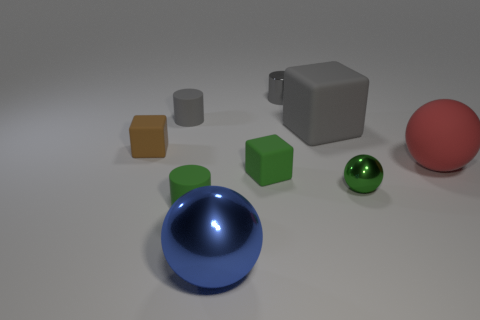Add 1 metal blocks. How many objects exist? 10 Subtract all cylinders. How many objects are left? 6 Add 2 gray cylinders. How many gray cylinders exist? 4 Subtract 1 brown blocks. How many objects are left? 8 Subtract all small green things. Subtract all tiny brown rubber cubes. How many objects are left? 5 Add 9 large shiny balls. How many large shiny balls are left? 10 